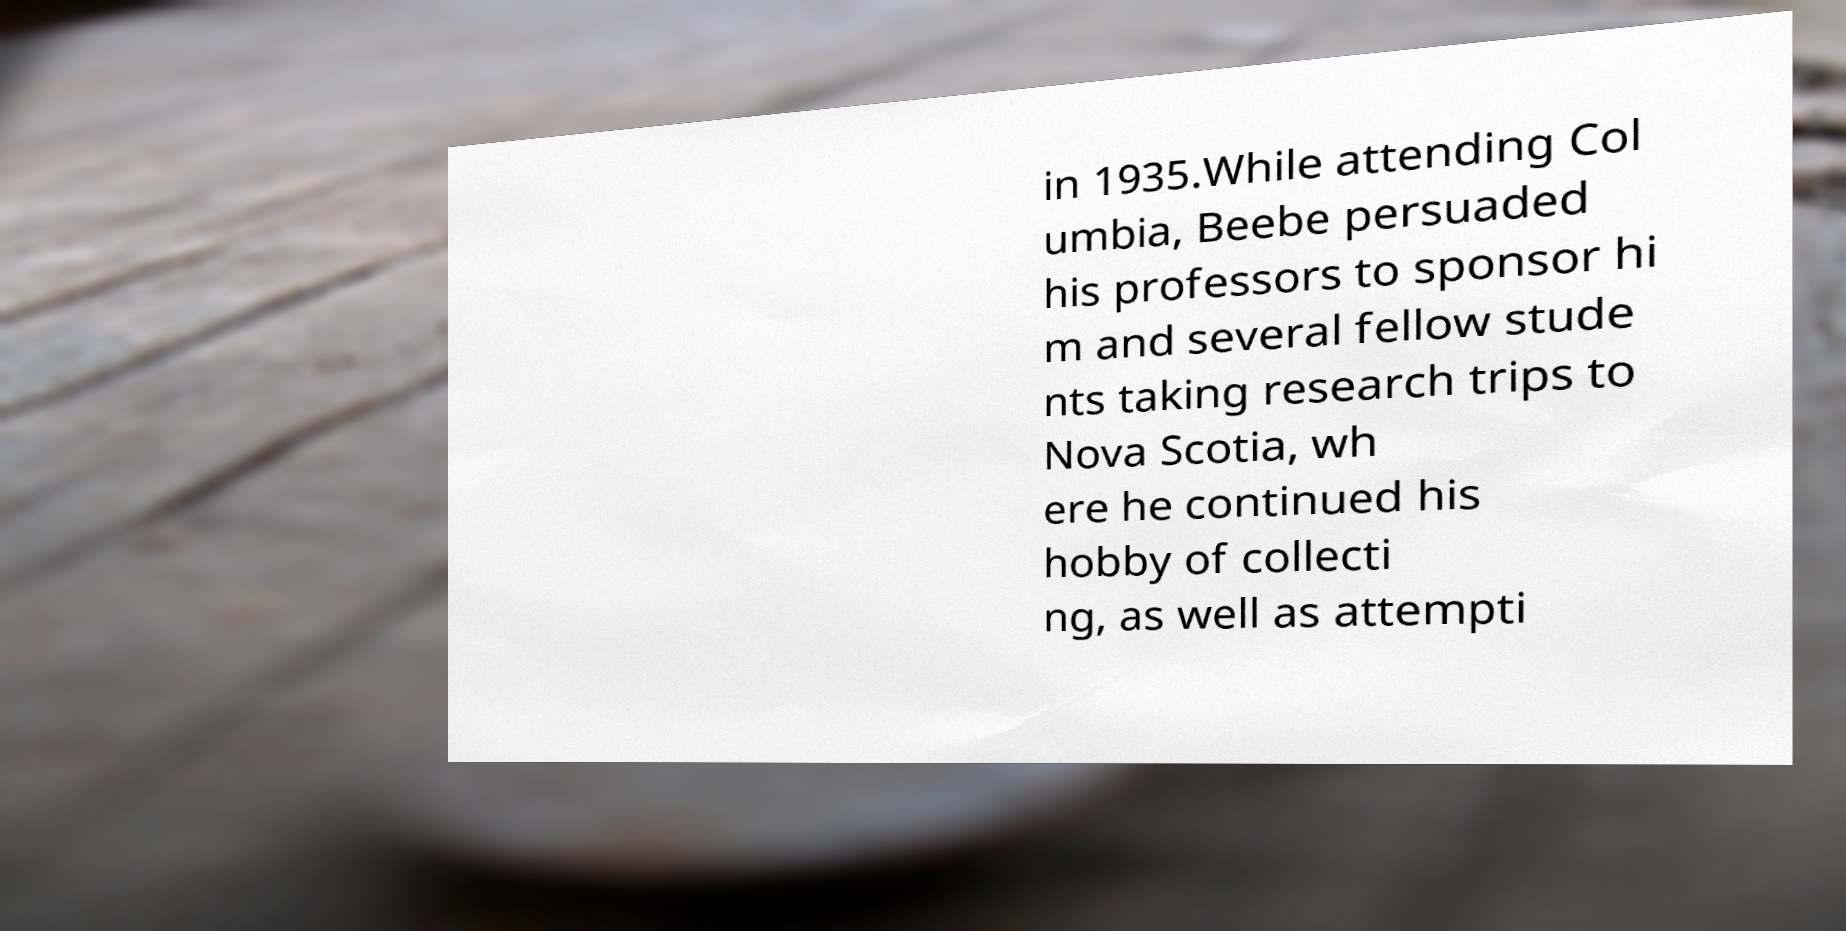Could you extract and type out the text from this image? in 1935.While attending Col umbia, Beebe persuaded his professors to sponsor hi m and several fellow stude nts taking research trips to Nova Scotia, wh ere he continued his hobby of collecti ng, as well as attempti 